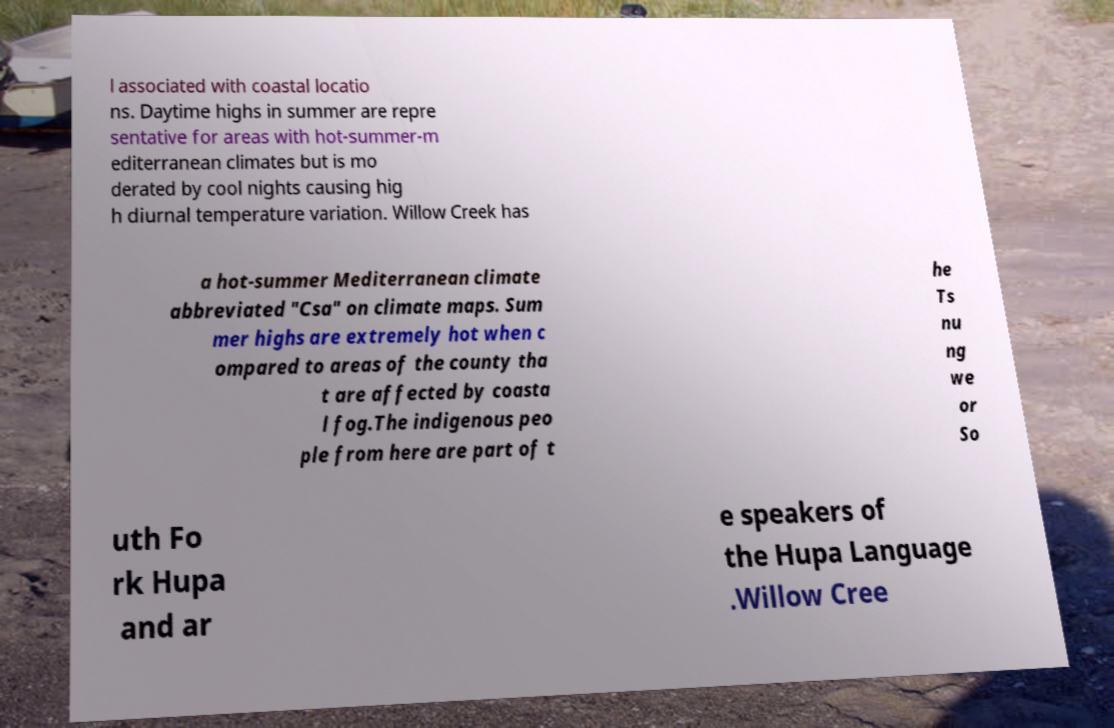Can you accurately transcribe the text from the provided image for me? l associated with coastal locatio ns. Daytime highs in summer are repre sentative for areas with hot-summer-m editerranean climates but is mo derated by cool nights causing hig h diurnal temperature variation. Willow Creek has a hot-summer Mediterranean climate abbreviated "Csa" on climate maps. Sum mer highs are extremely hot when c ompared to areas of the county tha t are affected by coasta l fog.The indigenous peo ple from here are part of t he Ts nu ng we or So uth Fo rk Hupa and ar e speakers of the Hupa Language .Willow Cree 